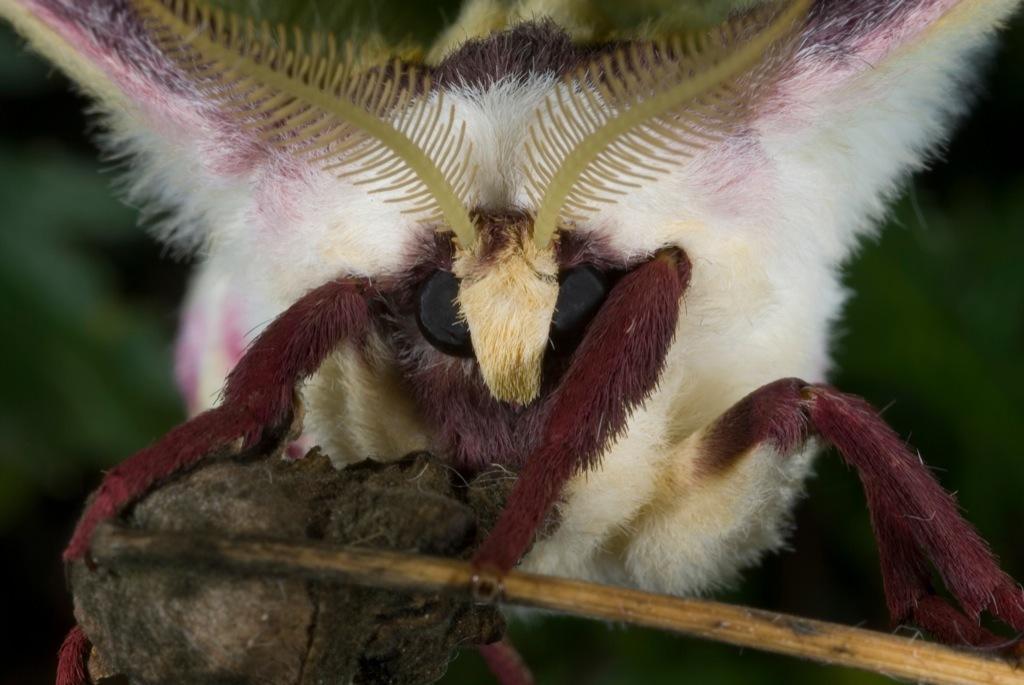What type of creature is present in the image? There is an insect in the image. What color is the insect? The insect is white in color. What can be seen in the background of the image? The background of the image is green. How is the background of the image depicted? The background is blurred. What type of popcorn is being served on the railway in the image? There is no popcorn or railway present in the image; it features a white insect against a green background. 